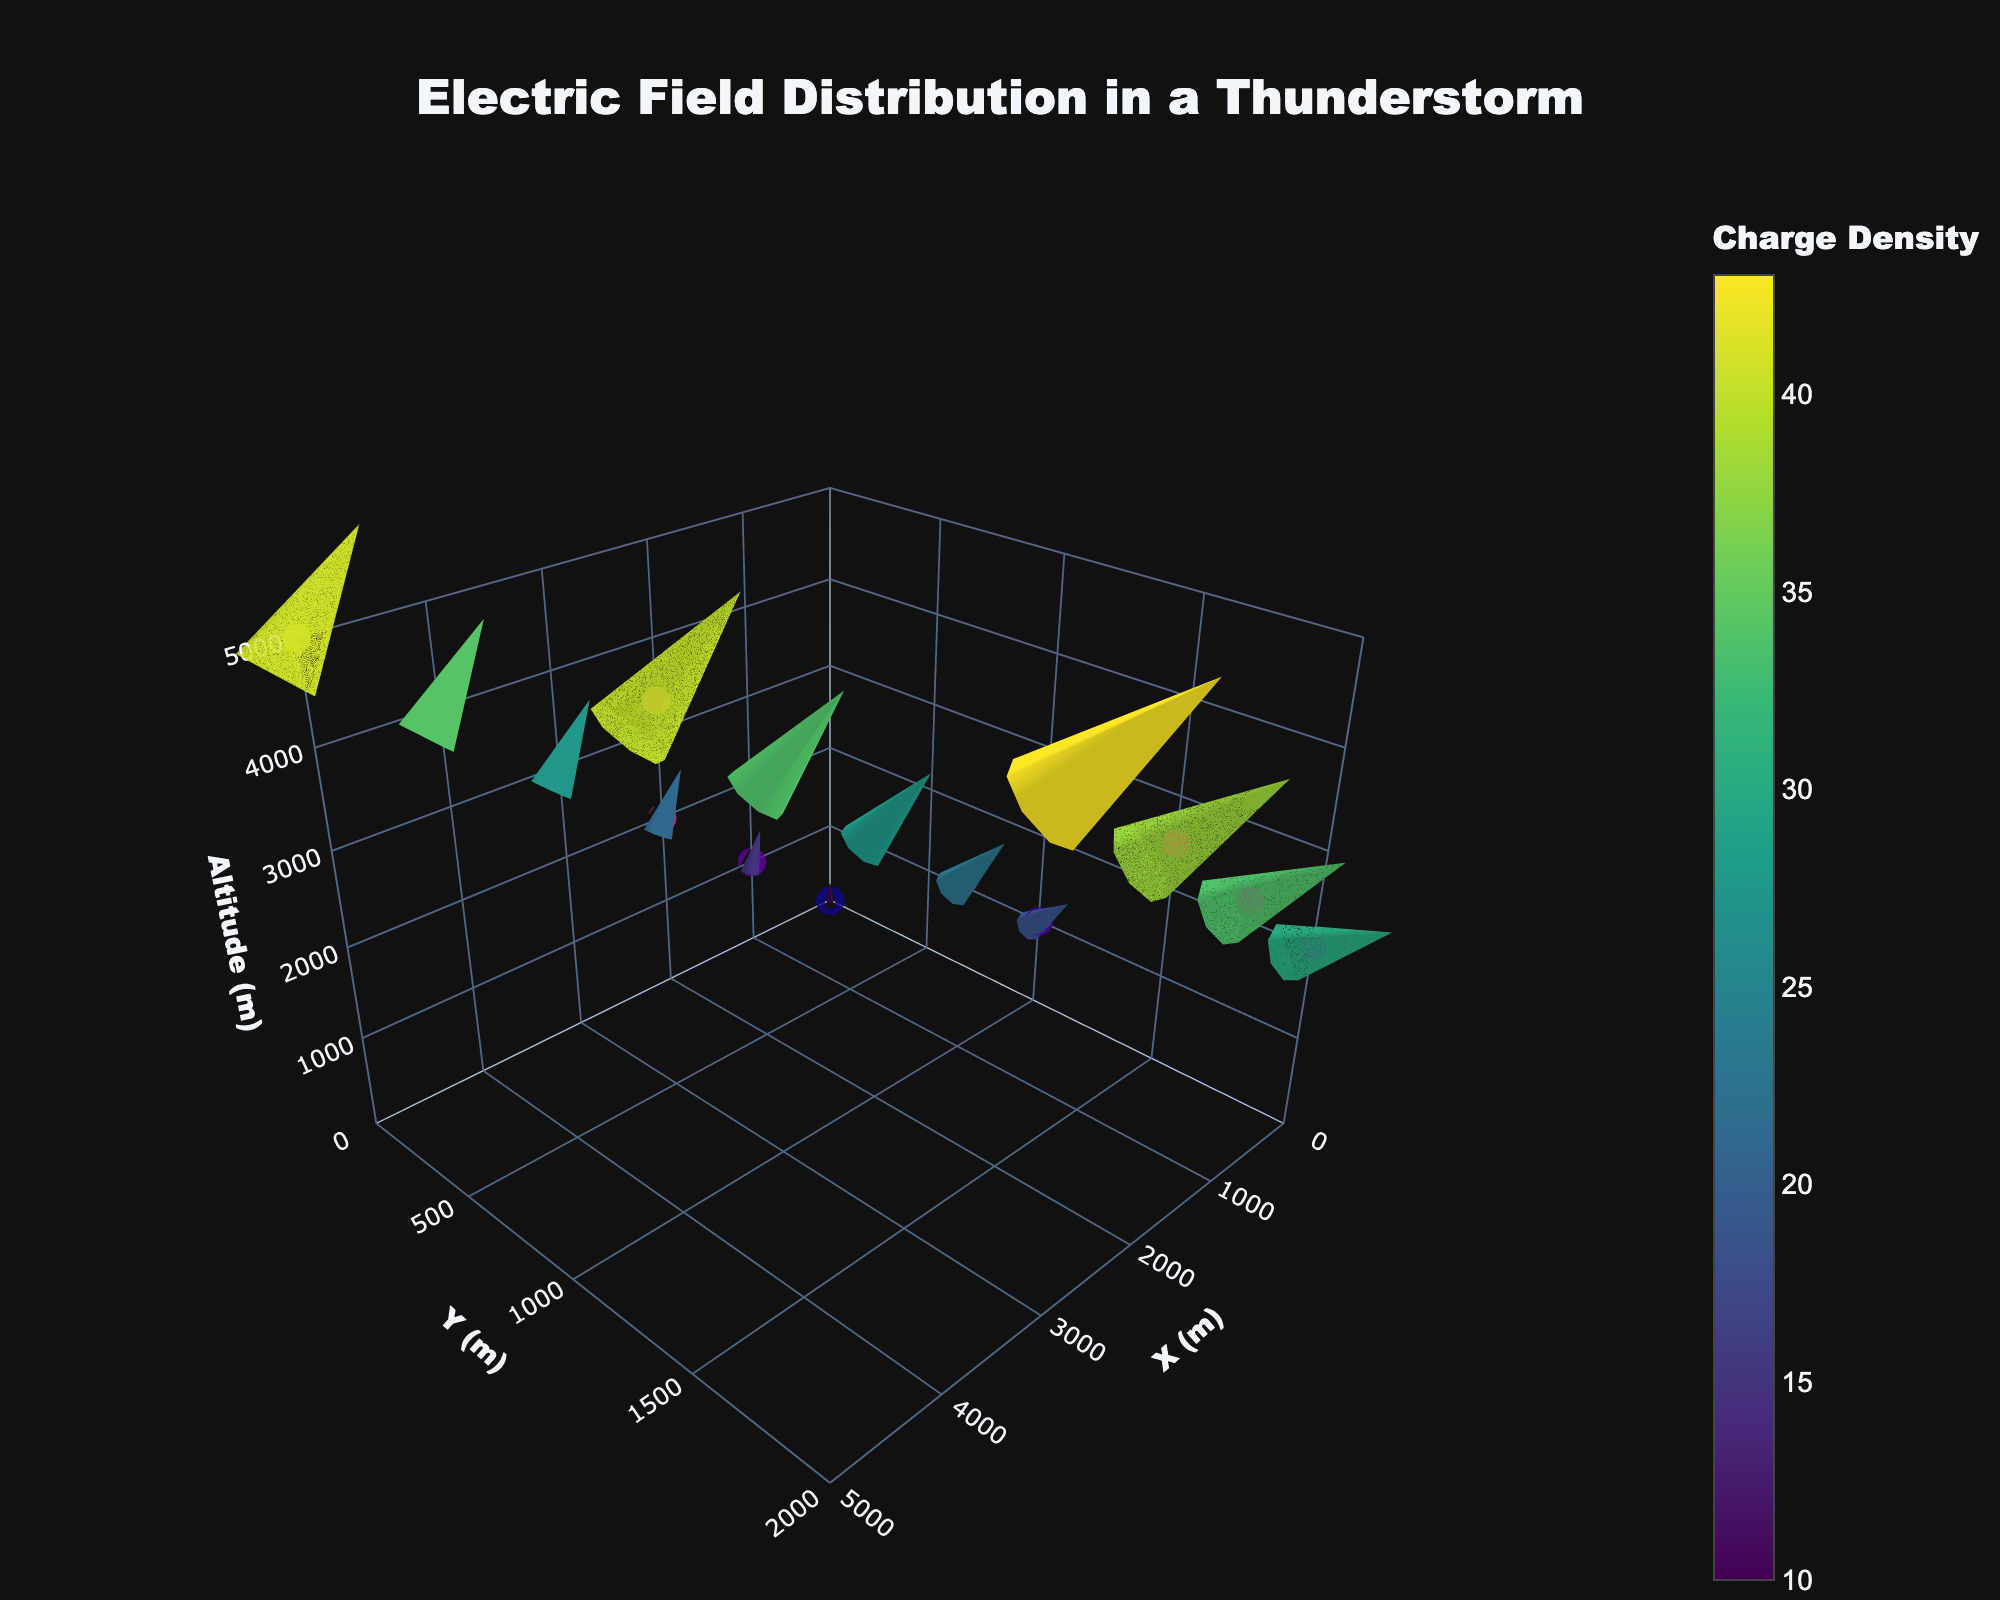What is the title of the figure? The title of the figure is displayed prominently at the top. It is "Electric Field Distribution in a Thunderstorm."
Answer: Electric Field Distribution in a Thunderstorm What are the ranges of the X, Y, and Z axes? The ranges of the axes are shown in the layout of the figure. The X axis ranges from 0 to 5000 meters, the Y axis ranges from 0 to 2000 meters, and the Z axis ranges from 0 to 5000 meters.
Answer: X: 0-5000 m, Y: 0-2000 m, Z: 0-5000 m What color scale is used to represent the charge density? The charge density is represented by a colorscale called "Plasma", as seen in the colorful markers in the quiver plot.
Answer: Plasma Which atmospheric level exhibits the highest charge density? By viewing the hover information in the scatter plot points, it is seen that the highest charge density is at the point with the coordinates (5000, 0, 5000) which shows a value of 2.1.
Answer: 5000, 0, 5000 How does the direction of the electric field change with altitude at (0, 0)? At coordinates (0, 0), as the altitude increases, the electric field direction changes along the Z-axis. From z=0 to z=3000, the field direction is upwards (Ex=0, Ey=0, and Ez=10, 15, and 20 respectively).
Answer: Upwards along Z-axis Compare the electric field intensity between the coordinates (1000, 0, 1000) and (3000, 0, 3000). Which one is higher? Electric field intensity can be derived from the components Ex, Ey, and Ez. At (1000, 0, 1000), the intensity is √((-5)^2 + 0^2 + 15^2) = √(250) ≈ 15.81. At (3000, 0, 3000), the intensity is √((-15)^2 + 0^2 + 25^2) = √(850) ≈ 29.15. Thus, (3000, 0, 3000) has a higher intensity.
Answer: (3000, 0, 3000) What is the electric field vector at the point (2000, 2000, 4000)? At (2000, 2000, 4000), the components of the electric field vector are given by (Ex, Ey, Ez) = (-10, 10, 30).
Answer: (-10, 10, 30) What is the charge density at the highest point plotted in the figure? The highest point plotted in the figure corresponds to z=5000 meters. At this level, the charge density is shown to be 2.1 at coordinates (5000, 0, 5000).
Answer: 2.1 Considering horizontal distances, how does the electric field's Ex component vary from x=0 to x=5000 at y=0 and z=5000? With y=0 and z=5000 held constant, the Ex component varies from 0 at x=0 to -25 at x=5000, showing a linearly decreasing trend.
Answer: Decreases from 0 to -25 